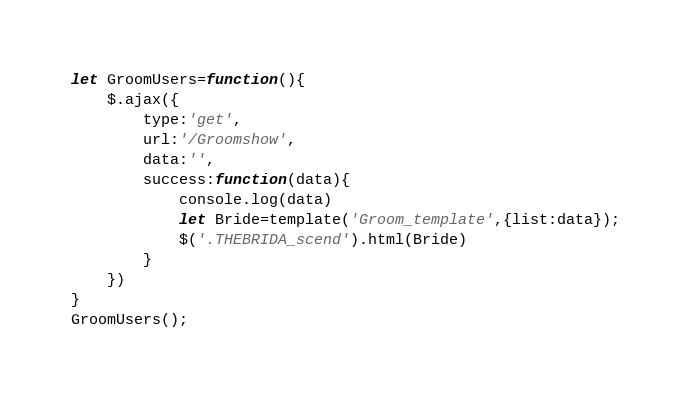<code> <loc_0><loc_0><loc_500><loc_500><_JavaScript_>let GroomUsers=function(){
    $.ajax({
        type:'get',
        url:'/Groomshow',
        data:'',
        success:function(data){
            console.log(data)
            let Bride=template('Groom_template',{list:data});
            $('.THEBRIDA_scend').html(Bride)
        }
    })
}
GroomUsers();</code> 